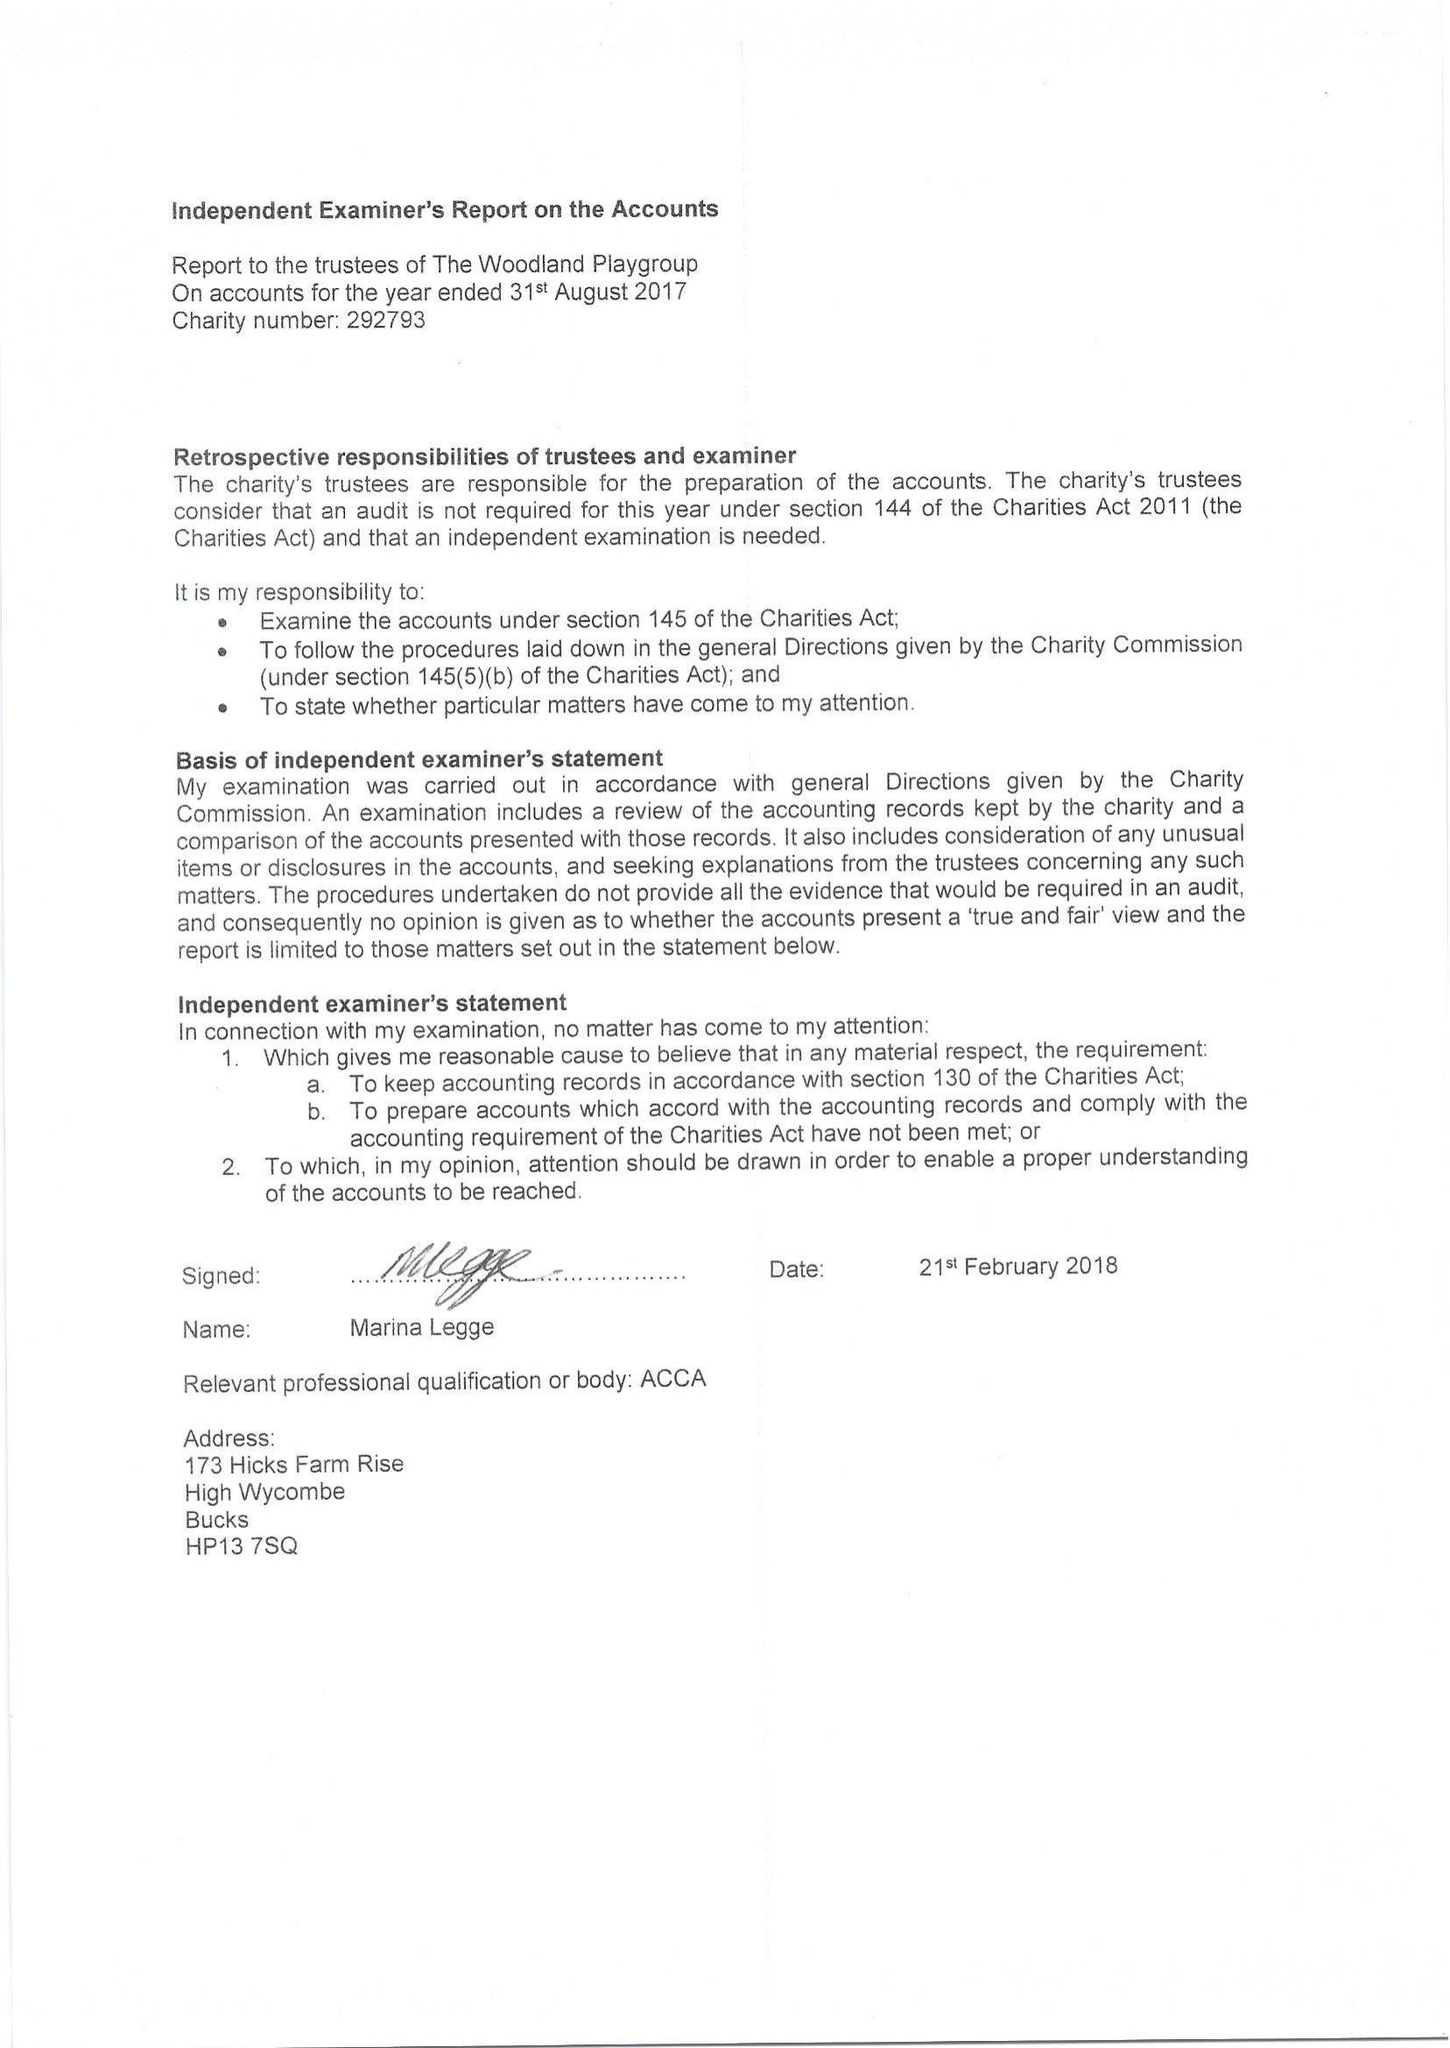What is the value for the income_annually_in_british_pounds?
Answer the question using a single word or phrase. 99658.00 